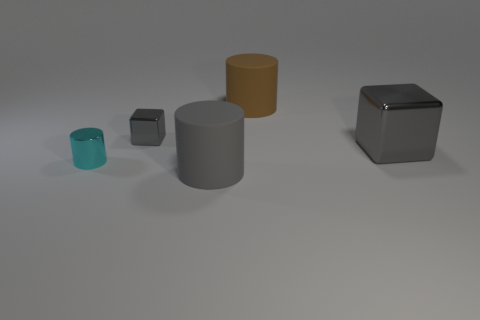What is the material of the small gray thing that is the same shape as the big shiny thing?
Your answer should be very brief. Metal. There is a tiny shiny block left of the large gray matte object; is it the same color as the large cylinder left of the large brown matte cylinder?
Provide a succinct answer. Yes. There is a small gray shiny thing; is its shape the same as the gray thing that is right of the big brown matte cylinder?
Your response must be concise. Yes. Are there fewer gray rubber objects on the right side of the brown thing than cylinders behind the cyan cylinder?
Ensure brevity in your answer.  Yes. Is the big brown thing the same shape as the small gray shiny object?
Your response must be concise. No. What size is the gray matte cylinder?
Offer a very short reply. Large. What color is the shiny object that is both right of the small cylinder and to the left of the large brown matte object?
Your response must be concise. Gray. Are there more large gray blocks than large brown metal balls?
Provide a short and direct response. Yes. How many objects are shiny cylinders or big matte objects behind the metal cylinder?
Ensure brevity in your answer.  2. Do the gray rubber cylinder and the shiny cylinder have the same size?
Provide a short and direct response. No. 